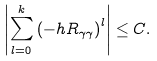Convert formula to latex. <formula><loc_0><loc_0><loc_500><loc_500>\left | \sum _ { l = 0 } ^ { k } \left ( - h R _ { \gamma \gamma } \right ) ^ { l } \right | \leq C .</formula> 